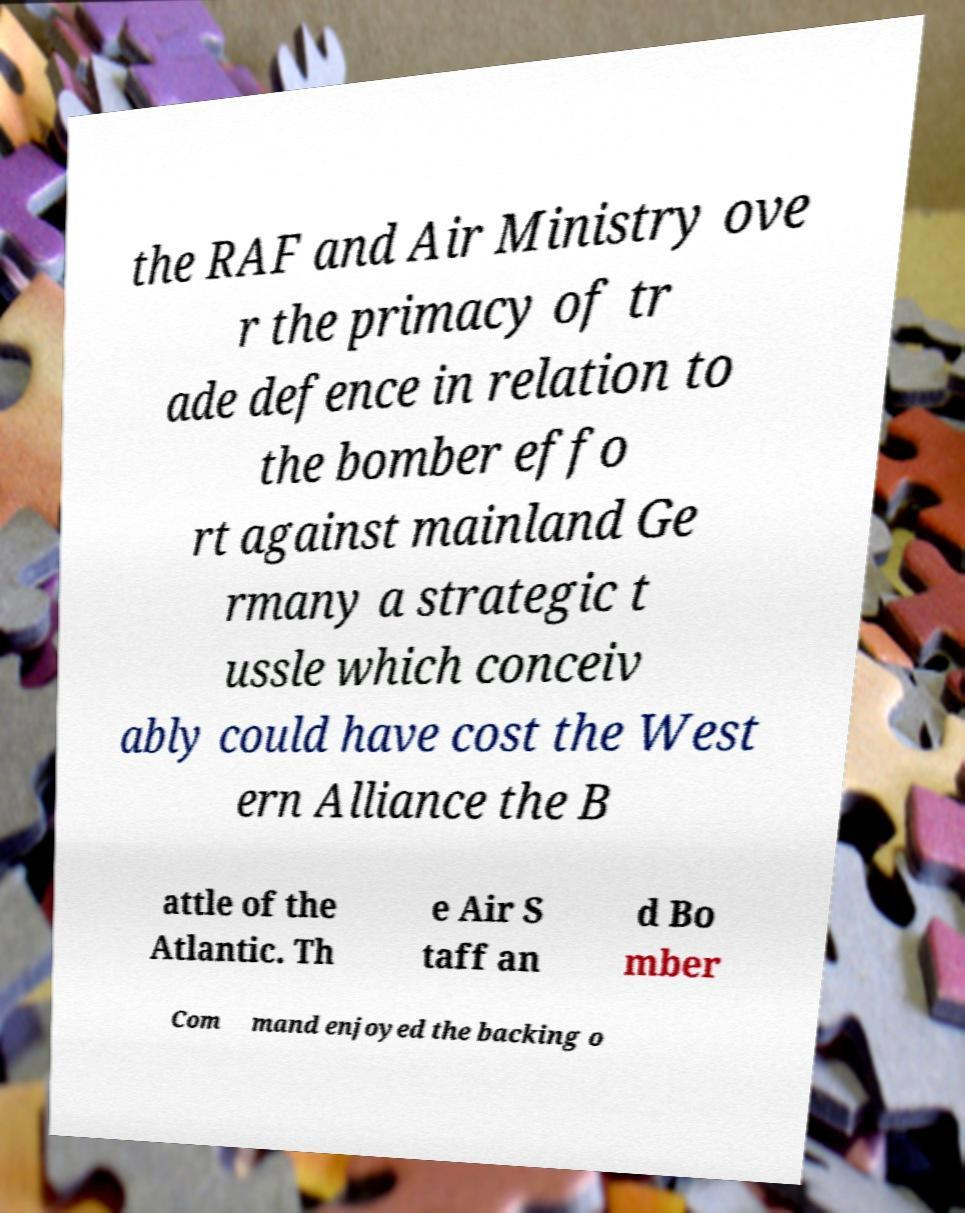There's text embedded in this image that I need extracted. Can you transcribe it verbatim? the RAF and Air Ministry ove r the primacy of tr ade defence in relation to the bomber effo rt against mainland Ge rmany a strategic t ussle which conceiv ably could have cost the West ern Alliance the B attle of the Atlantic. Th e Air S taff an d Bo mber Com mand enjoyed the backing o 